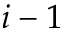<formula> <loc_0><loc_0><loc_500><loc_500>i - 1</formula> 